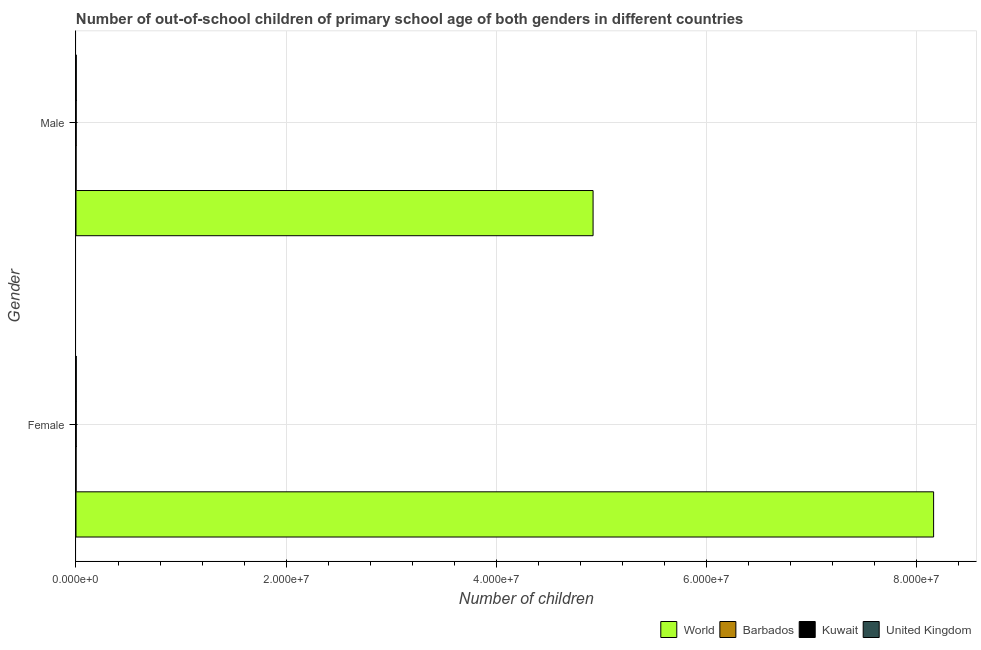How many different coloured bars are there?
Provide a succinct answer. 4. Are the number of bars on each tick of the Y-axis equal?
Provide a succinct answer. Yes. How many bars are there on the 1st tick from the top?
Ensure brevity in your answer.  4. How many bars are there on the 1st tick from the bottom?
Ensure brevity in your answer.  4. What is the number of male out-of-school students in Barbados?
Your response must be concise. 2413. Across all countries, what is the maximum number of female out-of-school students?
Ensure brevity in your answer.  8.16e+07. Across all countries, what is the minimum number of male out-of-school students?
Make the answer very short. 2413. In which country was the number of female out-of-school students maximum?
Offer a terse response. World. In which country was the number of male out-of-school students minimum?
Ensure brevity in your answer.  Barbados. What is the total number of male out-of-school students in the graph?
Provide a short and direct response. 4.92e+07. What is the difference between the number of male out-of-school students in Kuwait and that in Barbados?
Give a very brief answer. 1.19e+04. What is the difference between the number of female out-of-school students in World and the number of male out-of-school students in Barbados?
Provide a succinct answer. 8.16e+07. What is the average number of female out-of-school students per country?
Your answer should be very brief. 2.04e+07. What is the difference between the number of female out-of-school students and number of male out-of-school students in Kuwait?
Provide a short and direct response. 5083. What is the ratio of the number of male out-of-school students in World to that in Barbados?
Ensure brevity in your answer.  2.04e+04. Is the number of female out-of-school students in Barbados less than that in United Kingdom?
Give a very brief answer. Yes. In how many countries, is the number of male out-of-school students greater than the average number of male out-of-school students taken over all countries?
Provide a short and direct response. 1. What does the 3rd bar from the top in Male represents?
Your answer should be very brief. Barbados. How many bars are there?
Offer a very short reply. 8. What is the difference between two consecutive major ticks on the X-axis?
Your answer should be compact. 2.00e+07. Does the graph contain any zero values?
Ensure brevity in your answer.  No. Does the graph contain grids?
Provide a succinct answer. Yes. Where does the legend appear in the graph?
Provide a succinct answer. Bottom right. What is the title of the graph?
Make the answer very short. Number of out-of-school children of primary school age of both genders in different countries. What is the label or title of the X-axis?
Ensure brevity in your answer.  Number of children. What is the label or title of the Y-axis?
Your answer should be very brief. Gender. What is the Number of children in World in Female?
Your answer should be compact. 8.16e+07. What is the Number of children in Barbados in Female?
Keep it short and to the point. 2721. What is the Number of children of Kuwait in Female?
Ensure brevity in your answer.  1.94e+04. What is the Number of children of United Kingdom in Female?
Provide a short and direct response. 2.16e+04. What is the Number of children of World in Male?
Provide a succinct answer. 4.92e+07. What is the Number of children of Barbados in Male?
Your answer should be very brief. 2413. What is the Number of children in Kuwait in Male?
Make the answer very short. 1.43e+04. What is the Number of children in United Kingdom in Male?
Keep it short and to the point. 2.23e+04. Across all Gender, what is the maximum Number of children of World?
Your answer should be very brief. 8.16e+07. Across all Gender, what is the maximum Number of children of Barbados?
Offer a very short reply. 2721. Across all Gender, what is the maximum Number of children in Kuwait?
Make the answer very short. 1.94e+04. Across all Gender, what is the maximum Number of children of United Kingdom?
Keep it short and to the point. 2.23e+04. Across all Gender, what is the minimum Number of children of World?
Provide a short and direct response. 4.92e+07. Across all Gender, what is the minimum Number of children of Barbados?
Keep it short and to the point. 2413. Across all Gender, what is the minimum Number of children of Kuwait?
Your answer should be compact. 1.43e+04. Across all Gender, what is the minimum Number of children in United Kingdom?
Your answer should be compact. 2.16e+04. What is the total Number of children of World in the graph?
Provide a succinct answer. 1.31e+08. What is the total Number of children in Barbados in the graph?
Provide a short and direct response. 5134. What is the total Number of children in Kuwait in the graph?
Ensure brevity in your answer.  3.37e+04. What is the total Number of children in United Kingdom in the graph?
Offer a very short reply. 4.38e+04. What is the difference between the Number of children of World in Female and that in Male?
Make the answer very short. 3.24e+07. What is the difference between the Number of children in Barbados in Female and that in Male?
Ensure brevity in your answer.  308. What is the difference between the Number of children in Kuwait in Female and that in Male?
Your answer should be very brief. 5083. What is the difference between the Number of children of United Kingdom in Female and that in Male?
Offer a very short reply. -668. What is the difference between the Number of children in World in Female and the Number of children in Barbados in Male?
Offer a terse response. 8.16e+07. What is the difference between the Number of children in World in Female and the Number of children in Kuwait in Male?
Offer a terse response. 8.16e+07. What is the difference between the Number of children in World in Female and the Number of children in United Kingdom in Male?
Give a very brief answer. 8.16e+07. What is the difference between the Number of children in Barbados in Female and the Number of children in Kuwait in Male?
Give a very brief answer. -1.16e+04. What is the difference between the Number of children of Barbados in Female and the Number of children of United Kingdom in Male?
Your answer should be very brief. -1.95e+04. What is the difference between the Number of children of Kuwait in Female and the Number of children of United Kingdom in Male?
Offer a terse response. -2883. What is the average Number of children of World per Gender?
Offer a terse response. 6.54e+07. What is the average Number of children of Barbados per Gender?
Give a very brief answer. 2567. What is the average Number of children in Kuwait per Gender?
Ensure brevity in your answer.  1.68e+04. What is the average Number of children of United Kingdom per Gender?
Make the answer very short. 2.19e+04. What is the difference between the Number of children in World and Number of children in Barbados in Female?
Make the answer very short. 8.16e+07. What is the difference between the Number of children of World and Number of children of Kuwait in Female?
Your response must be concise. 8.16e+07. What is the difference between the Number of children in World and Number of children in United Kingdom in Female?
Provide a succinct answer. 8.16e+07. What is the difference between the Number of children in Barbados and Number of children in Kuwait in Female?
Your answer should be compact. -1.67e+04. What is the difference between the Number of children in Barbados and Number of children in United Kingdom in Female?
Make the answer very short. -1.89e+04. What is the difference between the Number of children in Kuwait and Number of children in United Kingdom in Female?
Make the answer very short. -2215. What is the difference between the Number of children in World and Number of children in Barbados in Male?
Offer a very short reply. 4.92e+07. What is the difference between the Number of children of World and Number of children of Kuwait in Male?
Your response must be concise. 4.92e+07. What is the difference between the Number of children of World and Number of children of United Kingdom in Male?
Offer a very short reply. 4.92e+07. What is the difference between the Number of children of Barbados and Number of children of Kuwait in Male?
Your answer should be compact. -1.19e+04. What is the difference between the Number of children of Barbados and Number of children of United Kingdom in Male?
Your answer should be compact. -1.98e+04. What is the difference between the Number of children in Kuwait and Number of children in United Kingdom in Male?
Your answer should be very brief. -7966. What is the ratio of the Number of children in World in Female to that in Male?
Give a very brief answer. 1.66. What is the ratio of the Number of children in Barbados in Female to that in Male?
Your response must be concise. 1.13. What is the ratio of the Number of children in Kuwait in Female to that in Male?
Your answer should be compact. 1.36. What is the ratio of the Number of children in United Kingdom in Female to that in Male?
Make the answer very short. 0.97. What is the difference between the highest and the second highest Number of children of World?
Your answer should be compact. 3.24e+07. What is the difference between the highest and the second highest Number of children in Barbados?
Keep it short and to the point. 308. What is the difference between the highest and the second highest Number of children in Kuwait?
Offer a very short reply. 5083. What is the difference between the highest and the second highest Number of children in United Kingdom?
Offer a terse response. 668. What is the difference between the highest and the lowest Number of children of World?
Provide a succinct answer. 3.24e+07. What is the difference between the highest and the lowest Number of children of Barbados?
Give a very brief answer. 308. What is the difference between the highest and the lowest Number of children in Kuwait?
Your answer should be compact. 5083. What is the difference between the highest and the lowest Number of children of United Kingdom?
Provide a short and direct response. 668. 